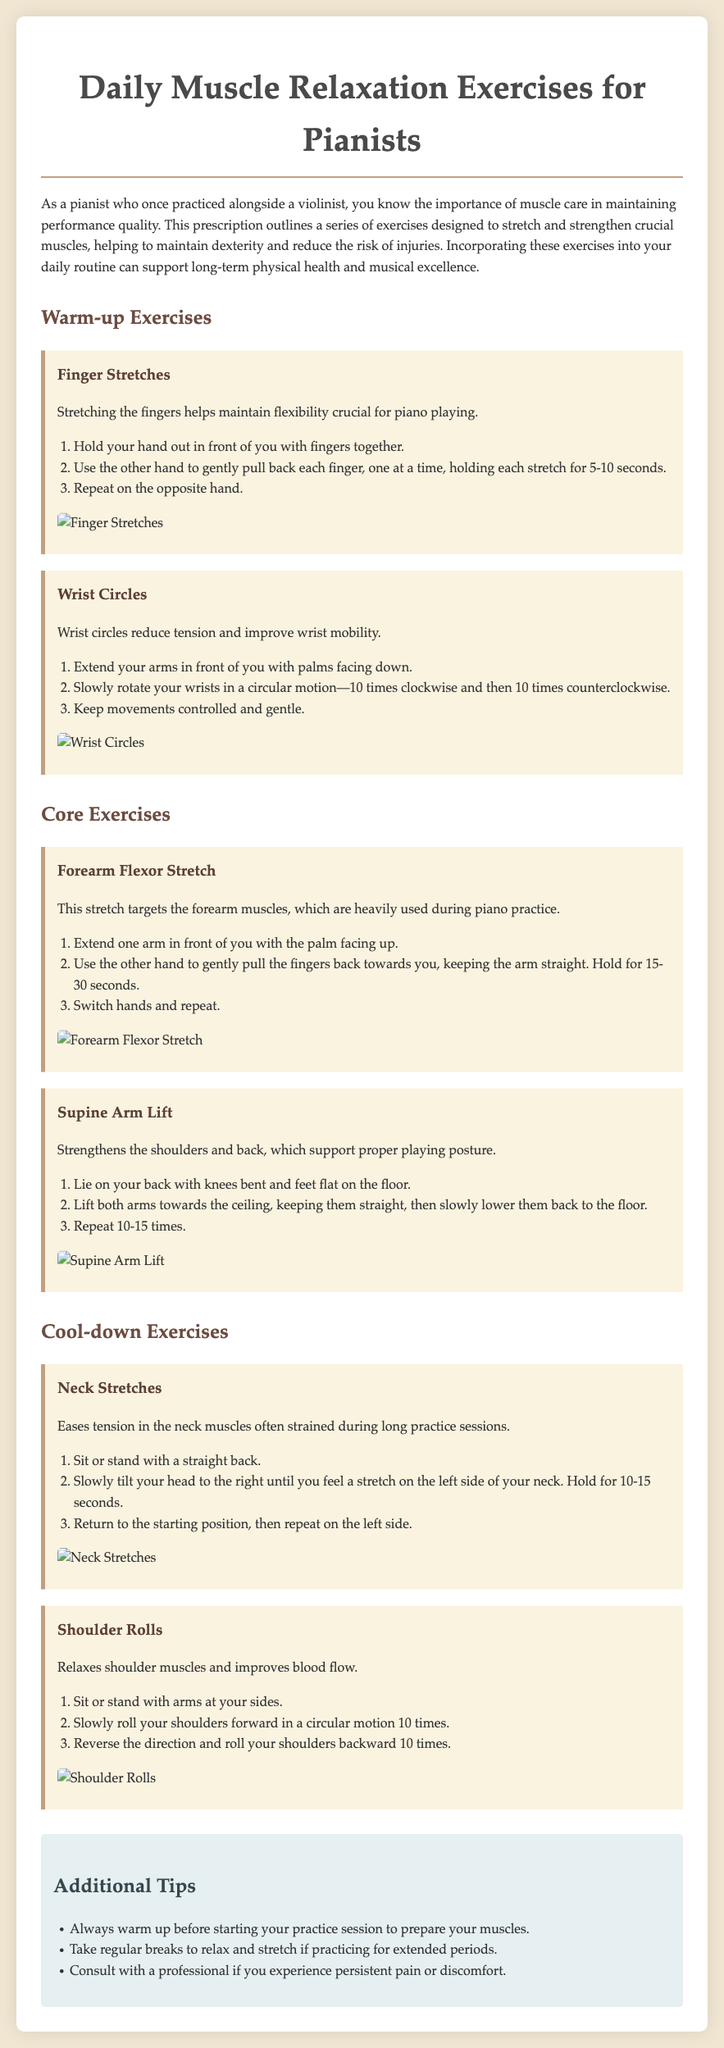What is the title of the document? The title of the document is presented prominently at the top of the prescription.
Answer: Daily Muscle Relaxation Exercises for Pianists How many warm-up exercises are listed? The document specifies the number of warm-up exercises under the Warm-up Exercises section.
Answer: Two What is one of the core exercises mentioned? The core exercises section includes a list of specific exercises targeted towards core muscle strength.
Answer: Forearm Flexor Stretch How long should you hold the Forearm Flexor Stretch? The duration for holding the Forearm Flexor Stretch is indicated in the exercise description.
Answer: 15-30 seconds What muscle group does the Supine Arm Lift target? The Supine Arm Lift is designed to strengthen specific muscles which are mentioned in the exercise details.
Answer: Shoulders and back What is suggested before starting a practice session? The document provides visitors with recommendations for preparing before they begin their practice.
Answer: Warm up How many shoulder rolls should you perform? The instruction specifies the number of shoulder rolls to perform in the exercise description.
Answer: Ten What should you do if you experience persistent pain or discomfort? The document includes advice regarding health concerns that may arise during practice sessions.
Answer: Consult a professional 